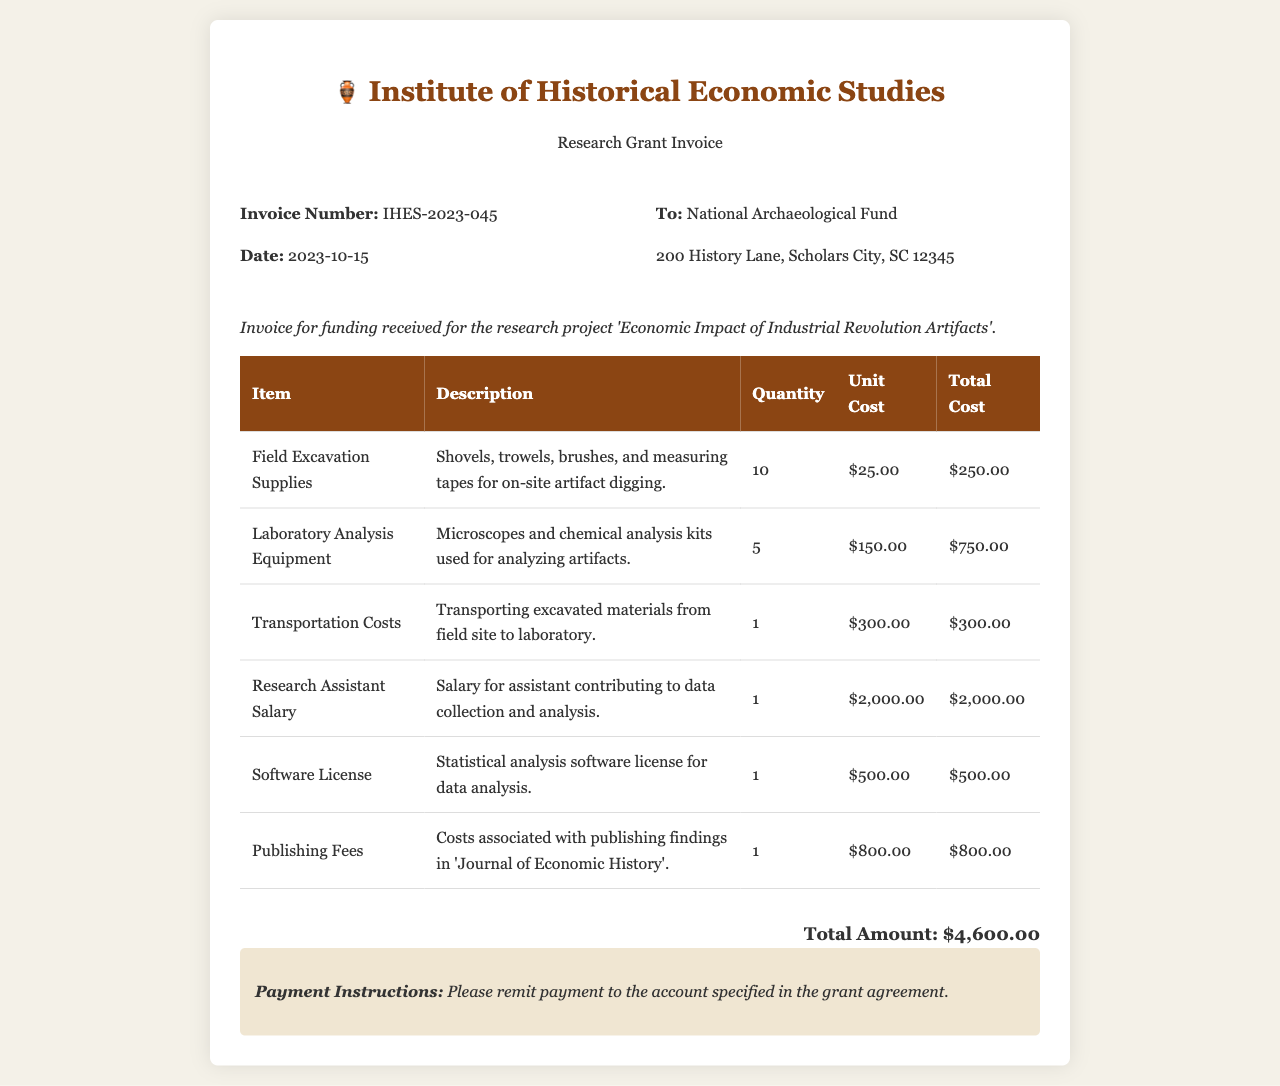What is the invoice number? The invoice number is a unique identifier for this specific invoice, listed in the document.
Answer: IHES-2023-045 What is the date of the invoice? The date indicates when the invoice was created, which is presented in the document.
Answer: 2023-10-15 Who is the invoice addressed to? The recipient's name is specified in the invoice details section.
Answer: National Archaeological Fund What is the total amount of the invoice? The total amount sums up all itemized expenditures listed in the table.
Answer: $4,600.00 How many Field Excavation Supplies were purchased? The quantity of a specific item, in this case, Field Excavation Supplies, is mentioned under its description.
Answer: 10 What is the unit cost of Laboratoire Analysis Equipment? The unit cost for each specific item is noted in the document.
Answer: $150.00 Which item has the highest total cost? This question requires comparing the total costs of all items listed to identify the highest.
Answer: Research Assistant Salary What is the purpose of this invoice? The purpose explains why the invoice was created and funded, mentioned in the introductory sentence.
Answer: Economic Impact of Industrial Revolution Artifacts What are the payment instructions? The payment instructions are provided in a separate section for clarity on how to settle the invoice.
Answer: Please remit payment to the account specified in the grant agreement 